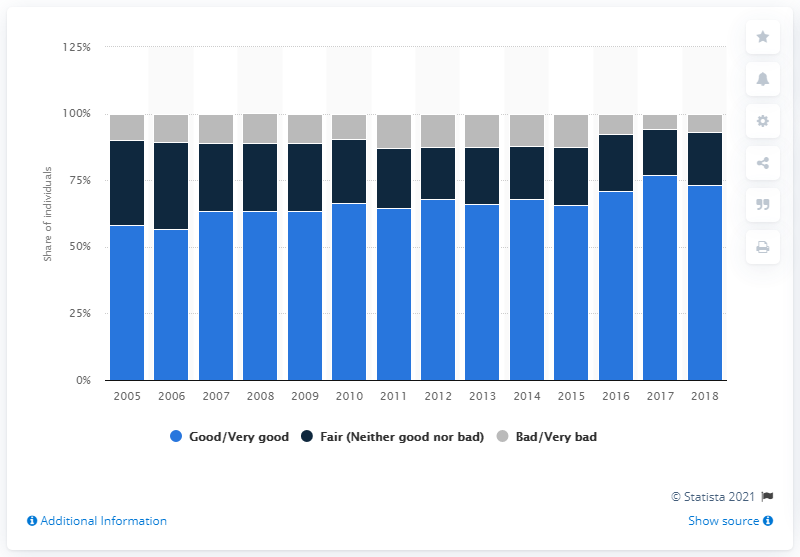Outline some significant characteristics in this image. In 2019, approximately 6.6% of individuals perceived their health state as bad or very bad. The state of health perception of people aged 15 years and older in Italy significantly improved in 2005. 